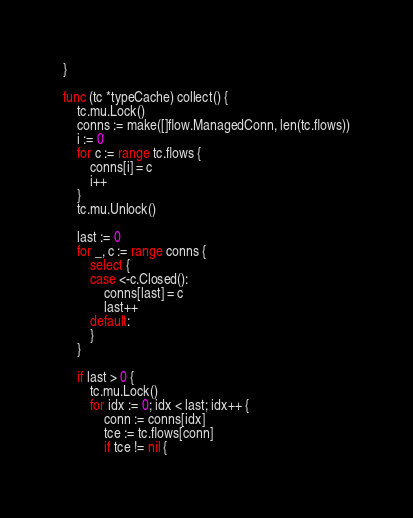<code> <loc_0><loc_0><loc_500><loc_500><_Go_>}

func (tc *typeCache) collect() {
	tc.mu.Lock()
	conns := make([]flow.ManagedConn, len(tc.flows))
	i := 0
	for c := range tc.flows {
		conns[i] = c
		i++
	}
	tc.mu.Unlock()

	last := 0
	for _, c := range conns {
		select {
		case <-c.Closed():
			conns[last] = c
			last++
		default:
		}
	}

	if last > 0 {
		tc.mu.Lock()
		for idx := 0; idx < last; idx++ {
			conn := conns[idx]
			tce := tc.flows[conn]
			if tce != nil {</code> 